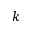Convert formula to latex. <formula><loc_0><loc_0><loc_500><loc_500>k</formula> 